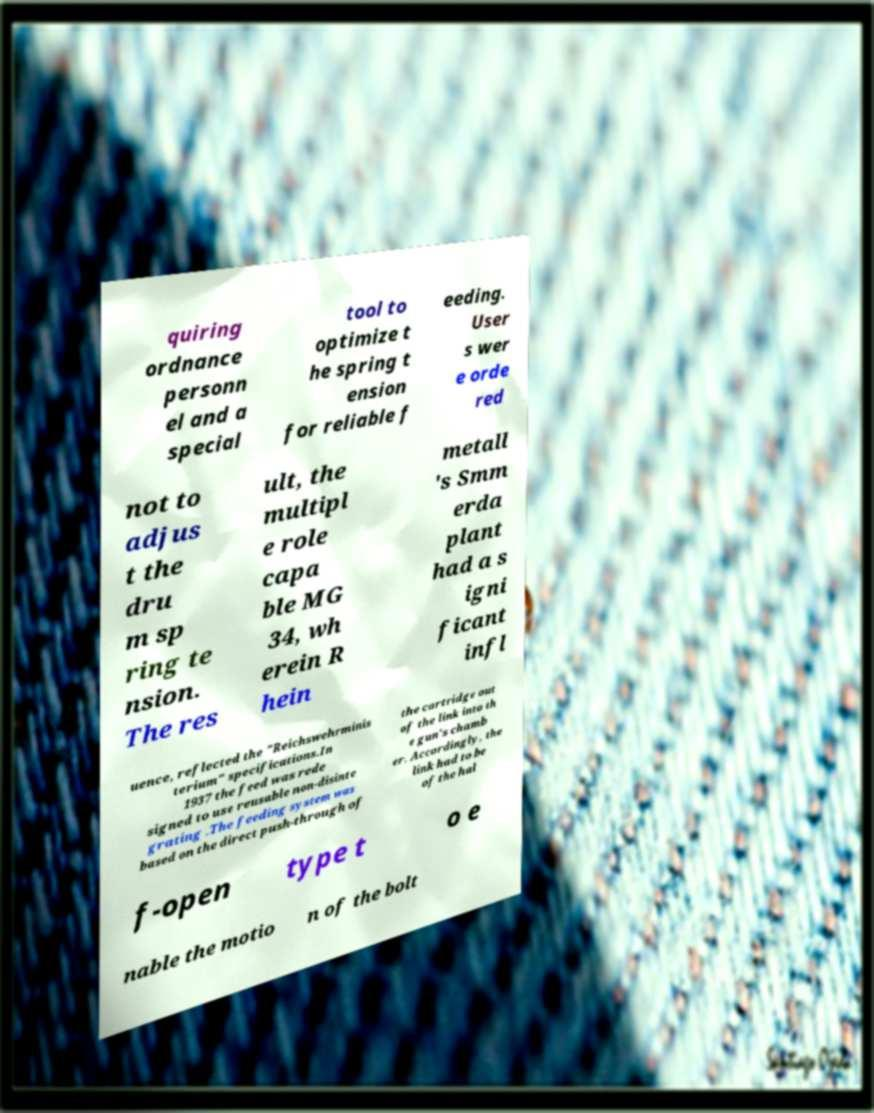What messages or text are displayed in this image? I need them in a readable, typed format. quiring ordnance personn el and a special tool to optimize t he spring t ension for reliable f eeding. User s wer e orde red not to adjus t the dru m sp ring te nsion. The res ult, the multipl e role capa ble MG 34, wh erein R hein metall 's Smm erda plant had a s igni ficant infl uence, reflected the "Reichswehrminis terium" specifications.In 1937 the feed was rede signed to use reusable non-disinte grating .The feeding system was based on the direct push-through of the cartridge out of the link into th e gun's chamb er. Accordingly, the link had to be of the hal f-open type t o e nable the motio n of the bolt 